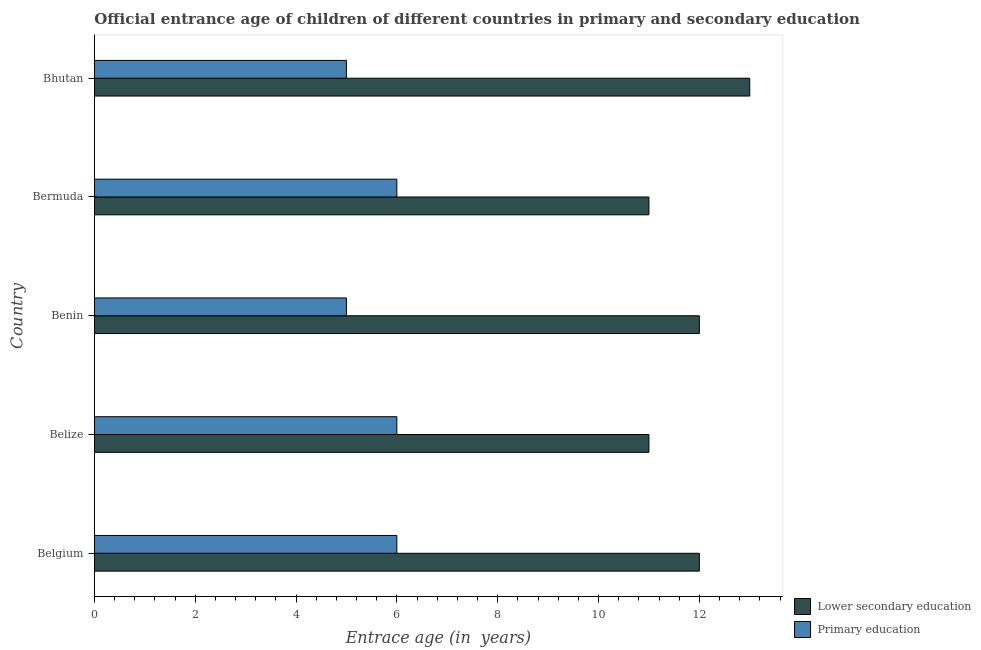How many different coloured bars are there?
Offer a terse response. 2. How many groups of bars are there?
Your answer should be very brief. 5. Are the number of bars per tick equal to the number of legend labels?
Provide a short and direct response. Yes. What is the label of the 2nd group of bars from the top?
Ensure brevity in your answer.  Bermuda. What is the entrance age of chiildren in primary education in Benin?
Make the answer very short. 5. Across all countries, what is the maximum entrance age of children in lower secondary education?
Keep it short and to the point. 13. Across all countries, what is the minimum entrance age of children in lower secondary education?
Provide a succinct answer. 11. In which country was the entrance age of chiildren in primary education maximum?
Offer a very short reply. Belgium. In which country was the entrance age of children in lower secondary education minimum?
Keep it short and to the point. Belize. What is the total entrance age of chiildren in primary education in the graph?
Your answer should be compact. 28. What is the difference between the entrance age of children in lower secondary education in Belgium and that in Bermuda?
Make the answer very short. 1. What is the difference between the entrance age of chiildren in primary education in Benin and the entrance age of children in lower secondary education in Belize?
Keep it short and to the point. -6. What is the difference between the entrance age of children in lower secondary education and entrance age of chiildren in primary education in Belize?
Your answer should be compact. 5. In how many countries, is the entrance age of children in lower secondary education greater than 6 years?
Offer a very short reply. 5. What is the ratio of the entrance age of chiildren in primary education in Benin to that in Bermuda?
Provide a succinct answer. 0.83. Is the difference between the entrance age of chiildren in primary education in Belize and Bhutan greater than the difference between the entrance age of children in lower secondary education in Belize and Bhutan?
Make the answer very short. Yes. What is the difference between the highest and the second highest entrance age of children in lower secondary education?
Make the answer very short. 1. What is the difference between the highest and the lowest entrance age of chiildren in primary education?
Ensure brevity in your answer.  1. In how many countries, is the entrance age of chiildren in primary education greater than the average entrance age of chiildren in primary education taken over all countries?
Keep it short and to the point. 3. Is the sum of the entrance age of children in lower secondary education in Benin and Bermuda greater than the maximum entrance age of chiildren in primary education across all countries?
Your response must be concise. Yes. What does the 2nd bar from the bottom in Bermuda represents?
Keep it short and to the point. Primary education. Are the values on the major ticks of X-axis written in scientific E-notation?
Ensure brevity in your answer.  No. Where does the legend appear in the graph?
Make the answer very short. Bottom right. What is the title of the graph?
Ensure brevity in your answer.  Official entrance age of children of different countries in primary and secondary education. What is the label or title of the X-axis?
Offer a very short reply. Entrace age (in  years). What is the Entrace age (in  years) in Primary education in Belgium?
Provide a short and direct response. 6. What is the Entrace age (in  years) in Primary education in Belize?
Provide a succinct answer. 6. What is the Entrace age (in  years) in Lower secondary education in Benin?
Your answer should be very brief. 12. What is the Entrace age (in  years) in Primary education in Bermuda?
Your answer should be very brief. 6. What is the Entrace age (in  years) of Lower secondary education in Bhutan?
Make the answer very short. 13. What is the Entrace age (in  years) in Primary education in Bhutan?
Your response must be concise. 5. Across all countries, what is the maximum Entrace age (in  years) of Lower secondary education?
Your response must be concise. 13. Across all countries, what is the maximum Entrace age (in  years) of Primary education?
Give a very brief answer. 6. What is the difference between the Entrace age (in  years) of Lower secondary education in Belgium and that in Belize?
Keep it short and to the point. 1. What is the difference between the Entrace age (in  years) of Primary education in Belgium and that in Belize?
Keep it short and to the point. 0. What is the difference between the Entrace age (in  years) in Lower secondary education in Belgium and that in Benin?
Offer a terse response. 0. What is the difference between the Entrace age (in  years) of Primary education in Belgium and that in Benin?
Provide a short and direct response. 1. What is the difference between the Entrace age (in  years) in Lower secondary education in Belgium and that in Bermuda?
Provide a short and direct response. 1. What is the difference between the Entrace age (in  years) in Lower secondary education in Belgium and that in Bhutan?
Offer a very short reply. -1. What is the difference between the Entrace age (in  years) of Primary education in Belgium and that in Bhutan?
Ensure brevity in your answer.  1. What is the difference between the Entrace age (in  years) of Lower secondary education in Belize and that in Benin?
Offer a very short reply. -1. What is the difference between the Entrace age (in  years) of Lower secondary education in Belize and that in Bhutan?
Offer a terse response. -2. What is the difference between the Entrace age (in  years) in Primary education in Belize and that in Bhutan?
Provide a succinct answer. 1. What is the difference between the Entrace age (in  years) in Primary education in Benin and that in Bhutan?
Offer a very short reply. 0. What is the difference between the Entrace age (in  years) of Lower secondary education in Bermuda and that in Bhutan?
Make the answer very short. -2. What is the difference between the Entrace age (in  years) in Lower secondary education in Belgium and the Entrace age (in  years) in Primary education in Belize?
Ensure brevity in your answer.  6. What is the difference between the Entrace age (in  years) in Lower secondary education in Belgium and the Entrace age (in  years) in Primary education in Benin?
Give a very brief answer. 7. What is the difference between the Entrace age (in  years) of Lower secondary education in Belgium and the Entrace age (in  years) of Primary education in Bermuda?
Your response must be concise. 6. What is the difference between the Entrace age (in  years) of Lower secondary education in Belgium and the Entrace age (in  years) of Primary education in Bhutan?
Make the answer very short. 7. What is the difference between the Entrace age (in  years) of Lower secondary education in Belize and the Entrace age (in  years) of Primary education in Benin?
Keep it short and to the point. 6. What is the difference between the Entrace age (in  years) in Lower secondary education in Benin and the Entrace age (in  years) in Primary education in Bermuda?
Your answer should be compact. 6. What is the average Entrace age (in  years) of Lower secondary education per country?
Your response must be concise. 11.8. What is the average Entrace age (in  years) in Primary education per country?
Provide a short and direct response. 5.6. What is the difference between the Entrace age (in  years) in Lower secondary education and Entrace age (in  years) in Primary education in Belgium?
Your answer should be very brief. 6. What is the difference between the Entrace age (in  years) of Lower secondary education and Entrace age (in  years) of Primary education in Belize?
Your response must be concise. 5. What is the difference between the Entrace age (in  years) in Lower secondary education and Entrace age (in  years) in Primary education in Bermuda?
Give a very brief answer. 5. What is the ratio of the Entrace age (in  years) in Primary education in Belgium to that in Benin?
Offer a terse response. 1.2. What is the ratio of the Entrace age (in  years) of Primary education in Belgium to that in Bermuda?
Provide a short and direct response. 1. What is the ratio of the Entrace age (in  years) of Lower secondary education in Belgium to that in Bhutan?
Your response must be concise. 0.92. What is the ratio of the Entrace age (in  years) in Lower secondary education in Belize to that in Benin?
Your answer should be very brief. 0.92. What is the ratio of the Entrace age (in  years) of Primary education in Belize to that in Benin?
Offer a very short reply. 1.2. What is the ratio of the Entrace age (in  years) of Lower secondary education in Belize to that in Bermuda?
Provide a short and direct response. 1. What is the ratio of the Entrace age (in  years) in Primary education in Belize to that in Bermuda?
Provide a short and direct response. 1. What is the ratio of the Entrace age (in  years) of Lower secondary education in Belize to that in Bhutan?
Your answer should be very brief. 0.85. What is the ratio of the Entrace age (in  years) in Primary education in Belize to that in Bhutan?
Offer a very short reply. 1.2. What is the ratio of the Entrace age (in  years) in Primary education in Benin to that in Bermuda?
Give a very brief answer. 0.83. What is the ratio of the Entrace age (in  years) in Primary education in Benin to that in Bhutan?
Ensure brevity in your answer.  1. What is the ratio of the Entrace age (in  years) in Lower secondary education in Bermuda to that in Bhutan?
Make the answer very short. 0.85. What is the ratio of the Entrace age (in  years) in Primary education in Bermuda to that in Bhutan?
Offer a very short reply. 1.2. What is the difference between the highest and the second highest Entrace age (in  years) of Primary education?
Your answer should be very brief. 0. What is the difference between the highest and the lowest Entrace age (in  years) of Lower secondary education?
Make the answer very short. 2. 